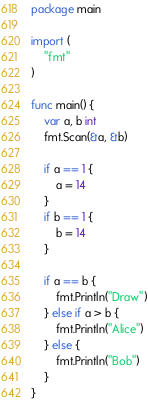Convert code to text. <code><loc_0><loc_0><loc_500><loc_500><_Go_>package main

import (
	"fmt"
)

func main() {
	var a, b int
	fmt.Scan(&a, &b)

	if a == 1 {
		a = 14
	}
	if b == 1 {
		b = 14
	}

	if a == b {
		fmt.Println("Draw")
	} else if a > b {
		fmt.Println("Alice")
	} else {
		fmt.Println("Bob")
	}
}
</code> 